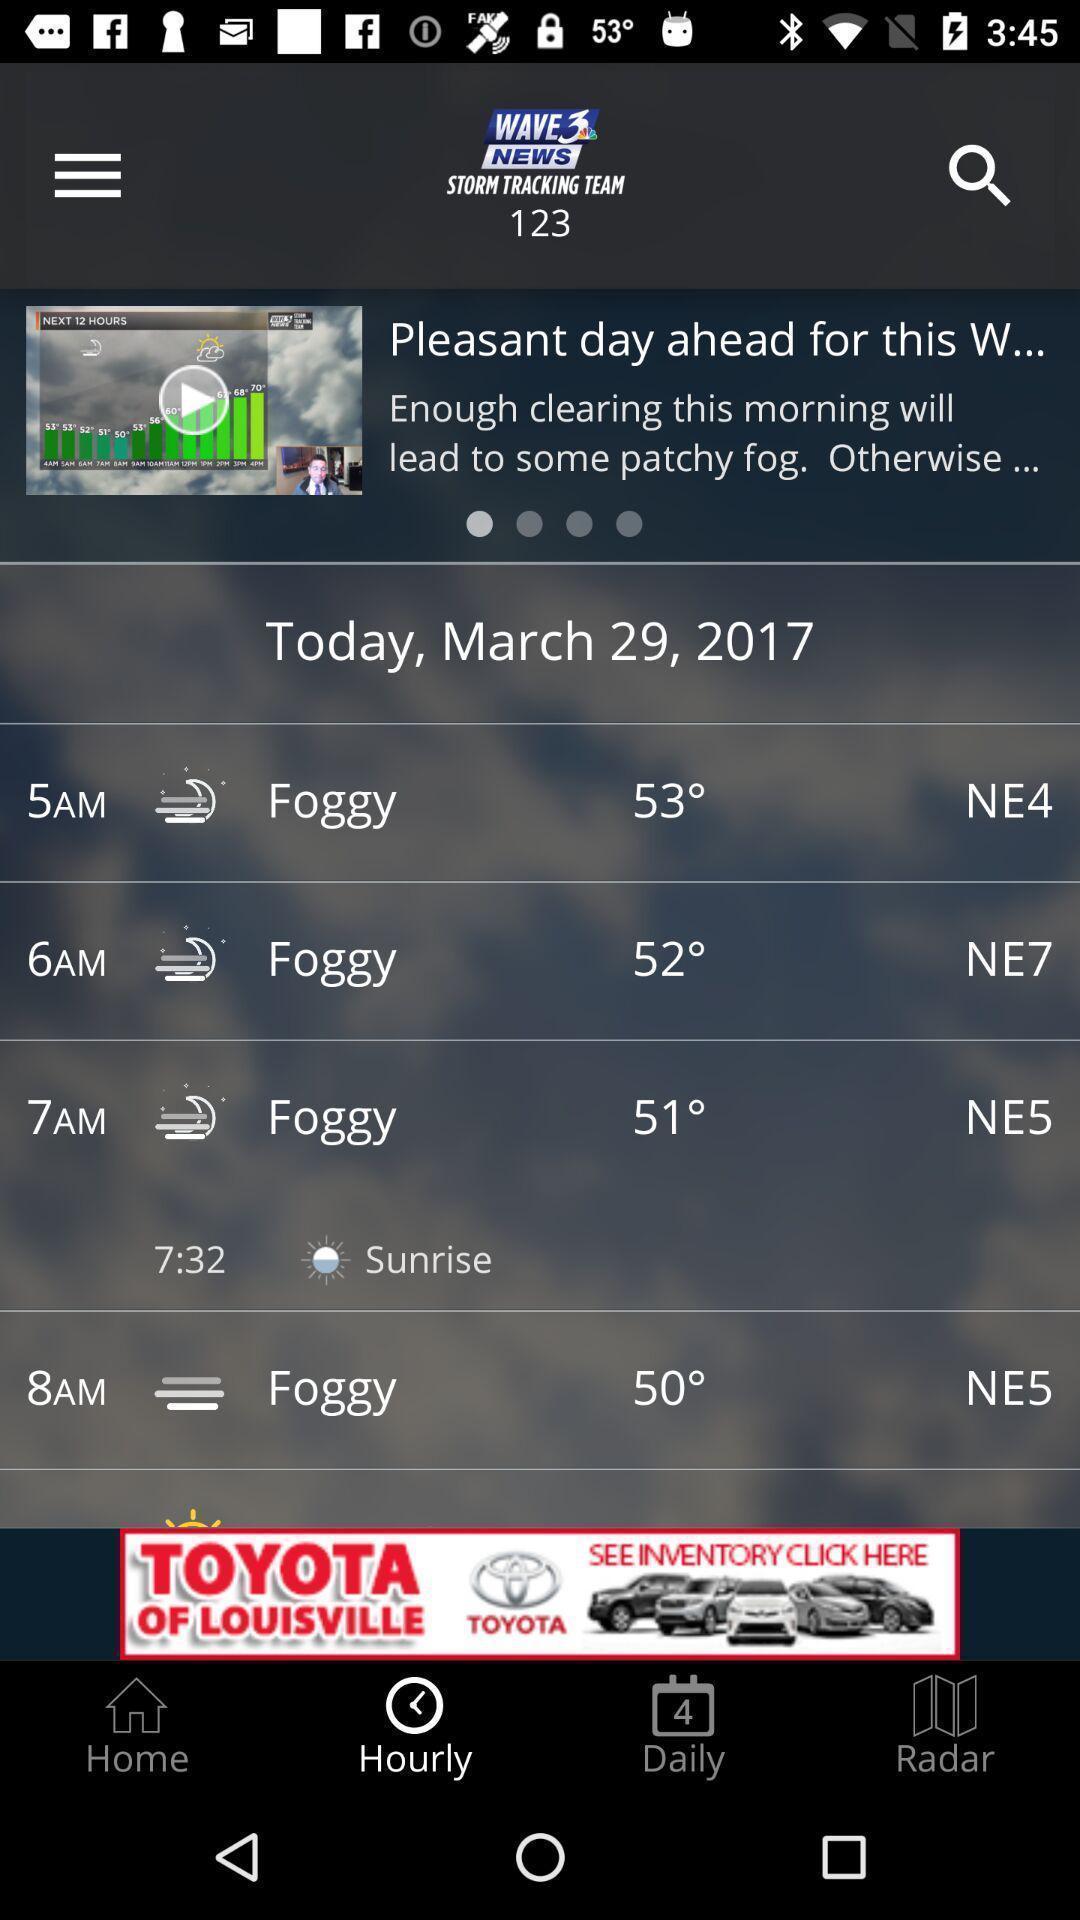Summarize the information in this screenshot. Weather information displaying in this page. 